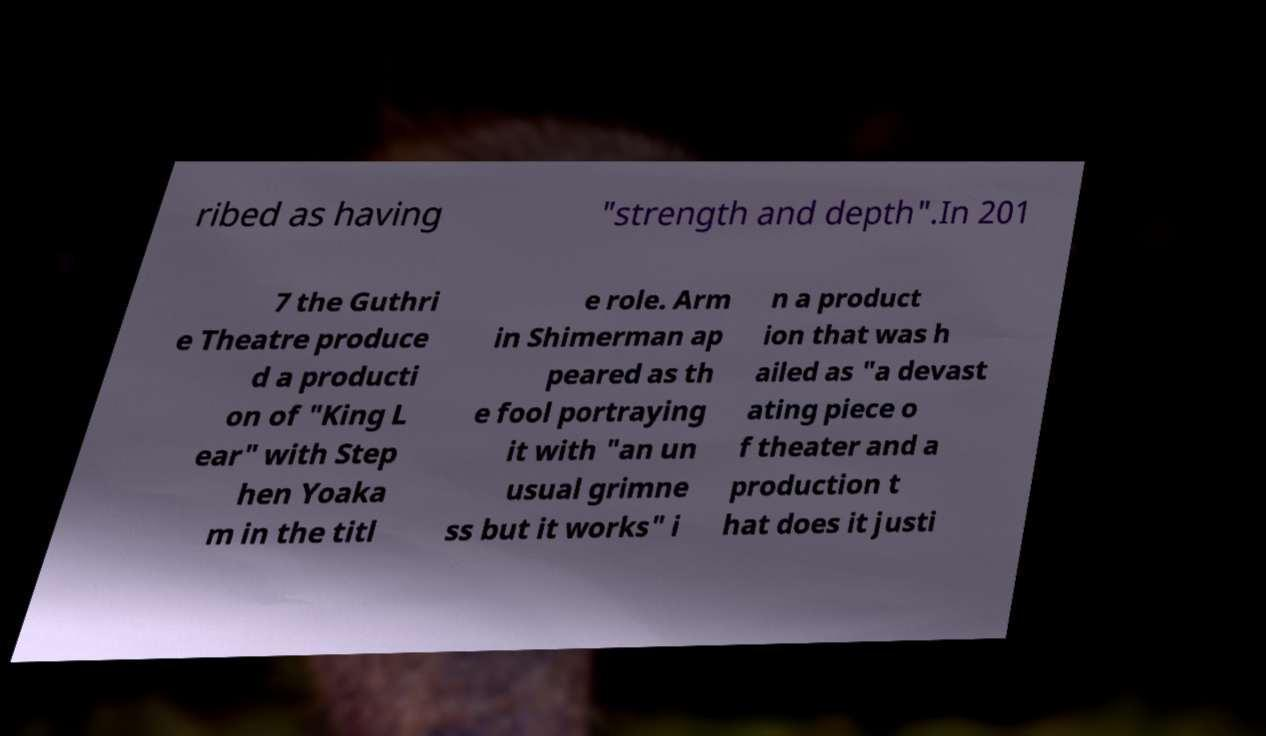Could you extract and type out the text from this image? ribed as having "strength and depth".In 201 7 the Guthri e Theatre produce d a producti on of "King L ear" with Step hen Yoaka m in the titl e role. Arm in Shimerman ap peared as th e fool portraying it with "an un usual grimne ss but it works" i n a product ion that was h ailed as "a devast ating piece o f theater and a production t hat does it justi 